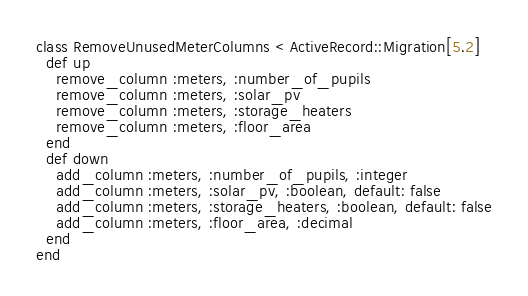Convert code to text. <code><loc_0><loc_0><loc_500><loc_500><_Ruby_>class RemoveUnusedMeterColumns < ActiveRecord::Migration[5.2]
  def up
    remove_column :meters, :number_of_pupils
    remove_column :meters, :solar_pv
    remove_column :meters, :storage_heaters
    remove_column :meters, :floor_area
  end
  def down
    add_column :meters, :number_of_pupils, :integer
    add_column :meters, :solar_pv, :boolean, default: false
    add_column :meters, :storage_heaters, :boolean, default: false
    add_column :meters, :floor_area, :decimal
  end
end
</code> 